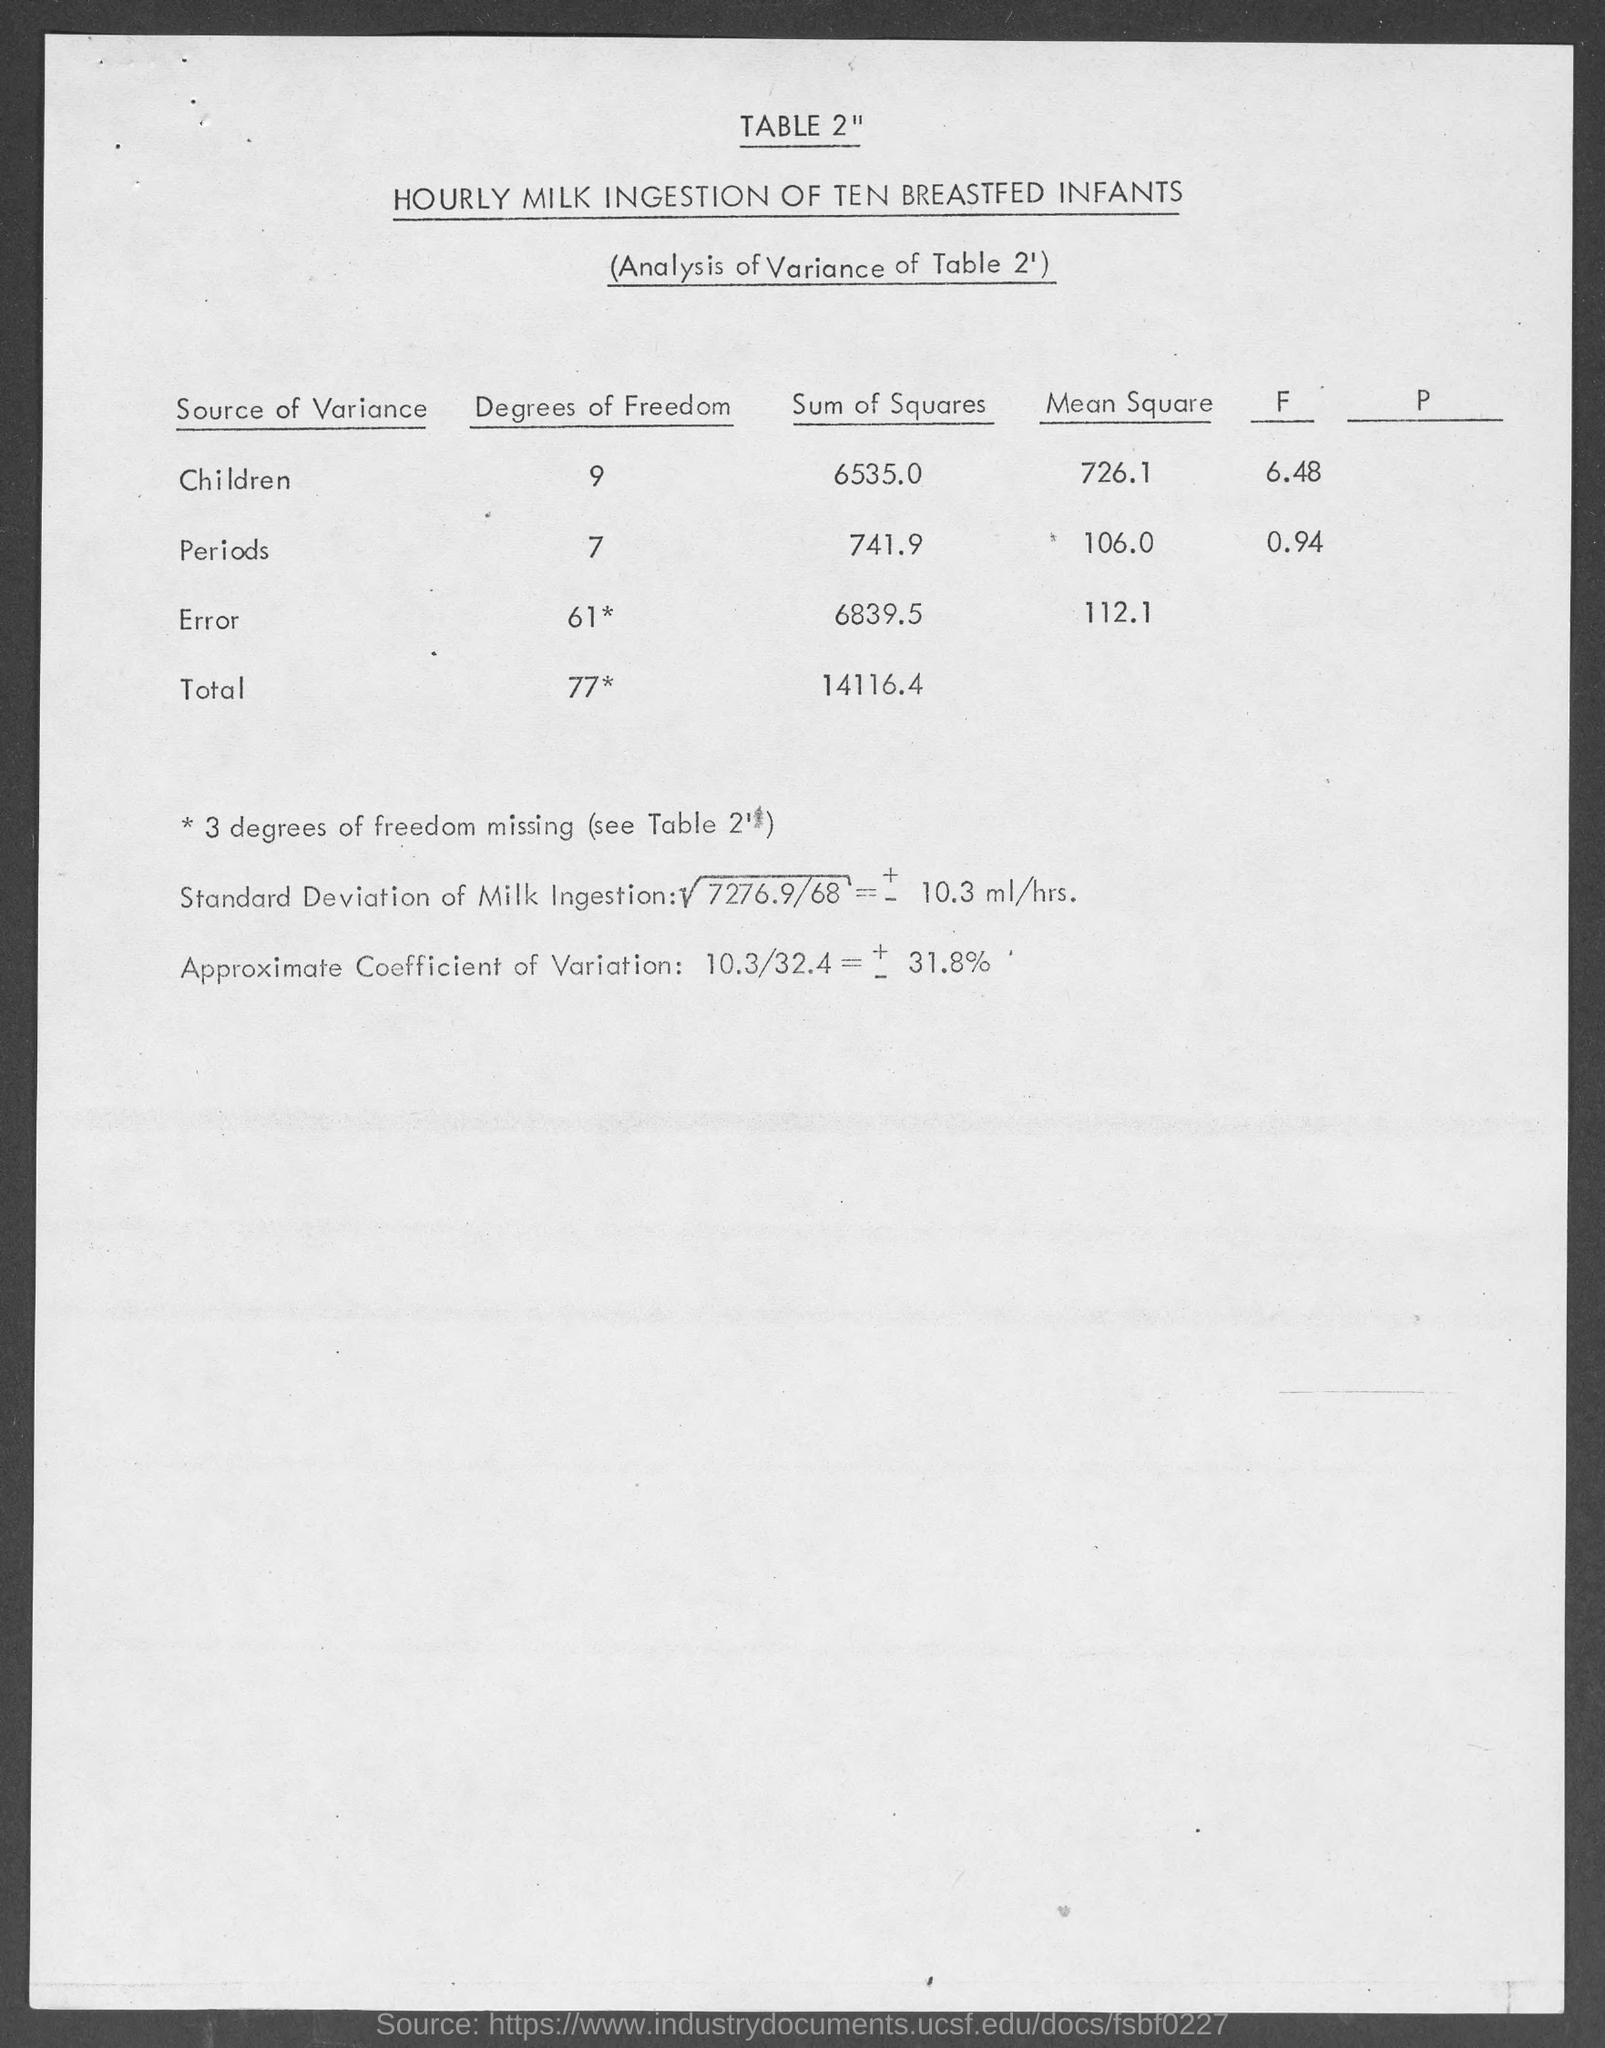What is the title of table 2" ?
Your response must be concise. HOURLY MILK INGESTION OF TEN BREASTFED INFANTS. What is the degrees of freedom for children ?
Make the answer very short. 9. What is the sum of squares for children?
Give a very brief answer. 6535.0. What is the mean square for children?
Your response must be concise. 726.1. What is the total degrees of freedom ?
Give a very brief answer. 77. What is the total sum of squares ?
Provide a succinct answer. 14116.4. 